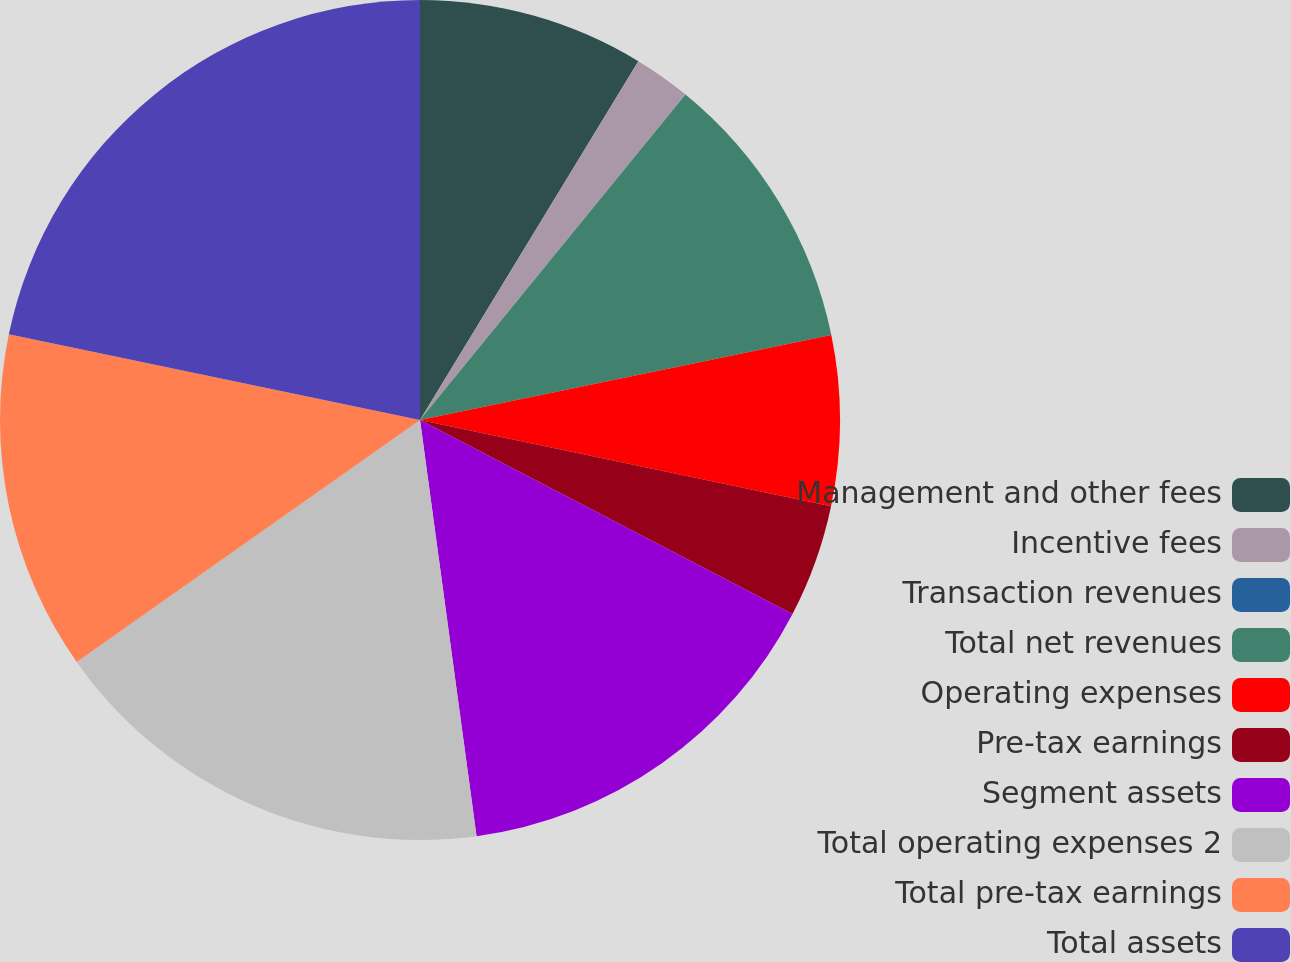Convert chart. <chart><loc_0><loc_0><loc_500><loc_500><pie_chart><fcel>Management and other fees<fcel>Incentive fees<fcel>Transaction revenues<fcel>Total net revenues<fcel>Operating expenses<fcel>Pre-tax earnings<fcel>Segment assets<fcel>Total operating expenses 2<fcel>Total pre-tax earnings<fcel>Total assets<nl><fcel>8.7%<fcel>2.18%<fcel>0.01%<fcel>10.87%<fcel>6.53%<fcel>4.35%<fcel>15.21%<fcel>17.38%<fcel>13.04%<fcel>21.73%<nl></chart> 